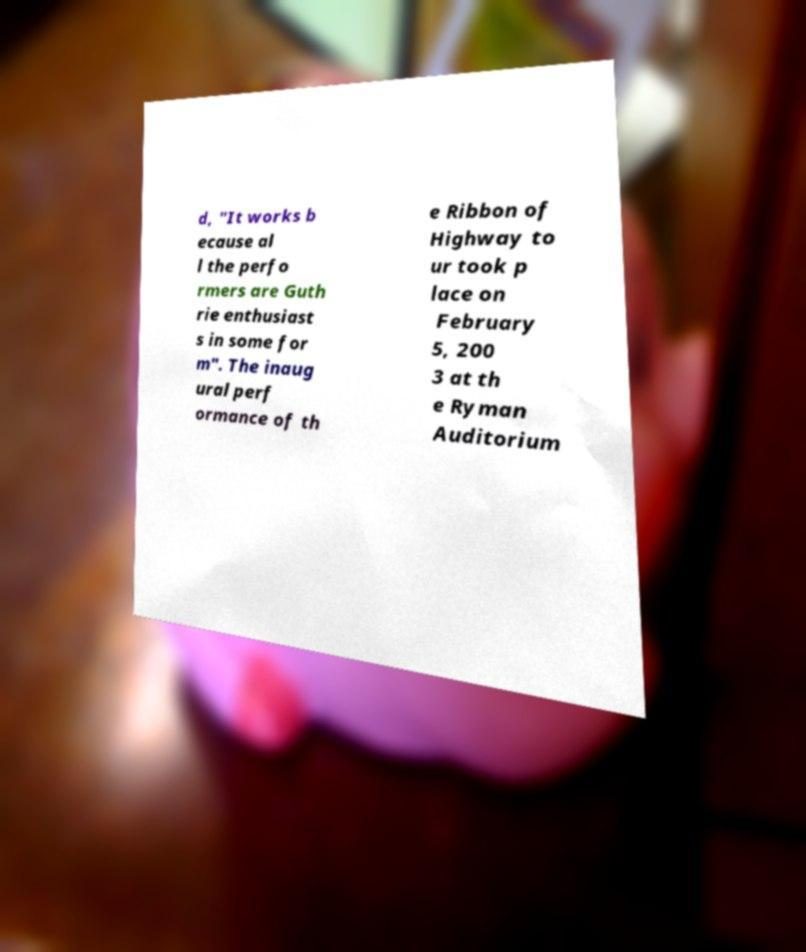Can you read and provide the text displayed in the image?This photo seems to have some interesting text. Can you extract and type it out for me? d, "It works b ecause al l the perfo rmers are Guth rie enthusiast s in some for m". The inaug ural perf ormance of th e Ribbon of Highway to ur took p lace on February 5, 200 3 at th e Ryman Auditorium 